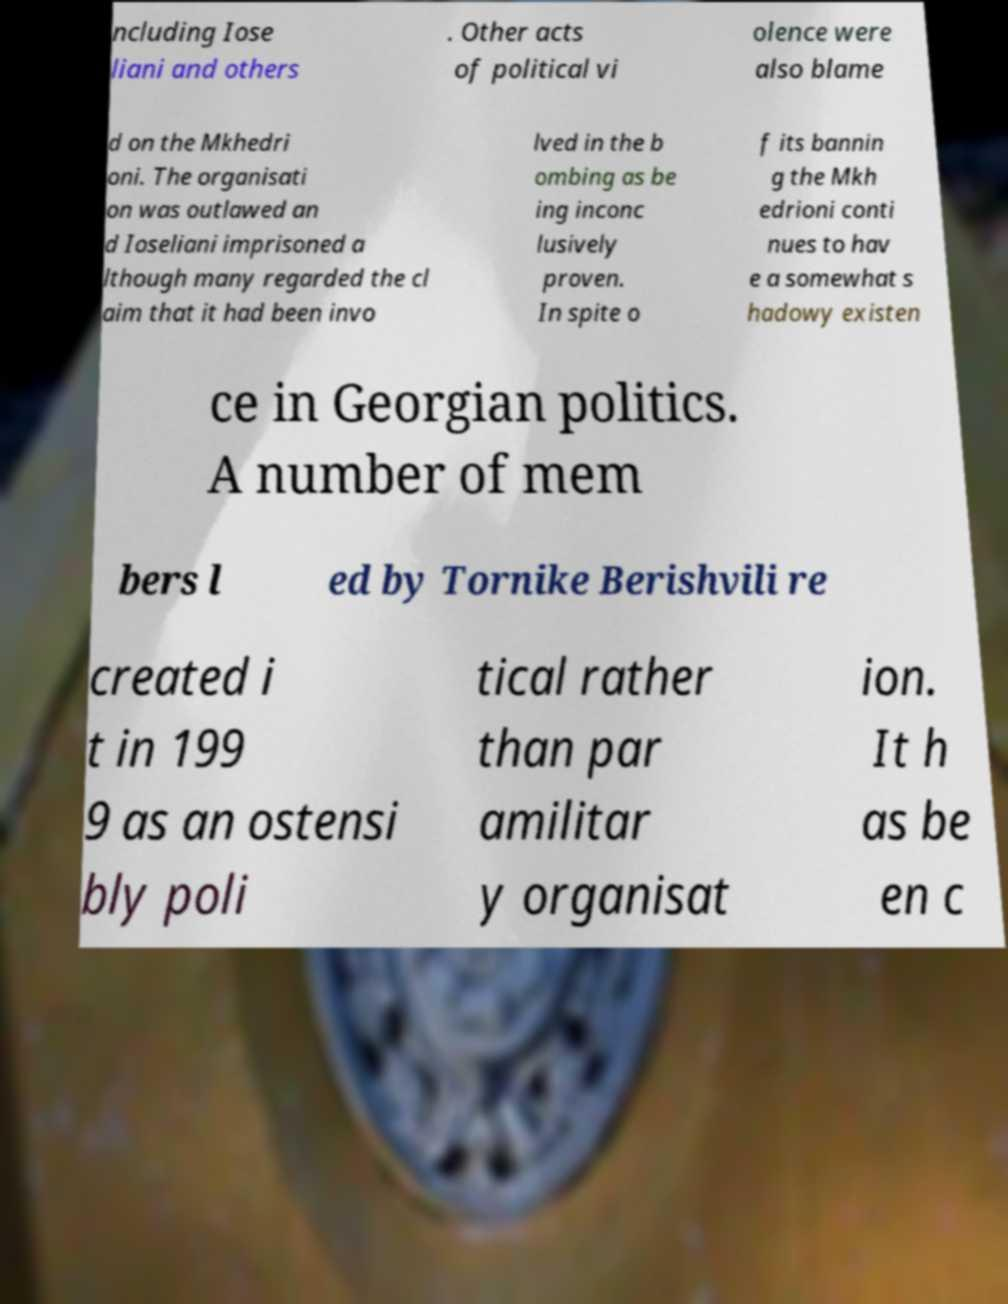There's text embedded in this image that I need extracted. Can you transcribe it verbatim? ncluding Iose liani and others . Other acts of political vi olence were also blame d on the Mkhedri oni. The organisati on was outlawed an d Ioseliani imprisoned a lthough many regarded the cl aim that it had been invo lved in the b ombing as be ing inconc lusively proven. In spite o f its bannin g the Mkh edrioni conti nues to hav e a somewhat s hadowy existen ce in Georgian politics. A number of mem bers l ed by Tornike Berishvili re created i t in 199 9 as an ostensi bly poli tical rather than par amilitar y organisat ion. It h as be en c 